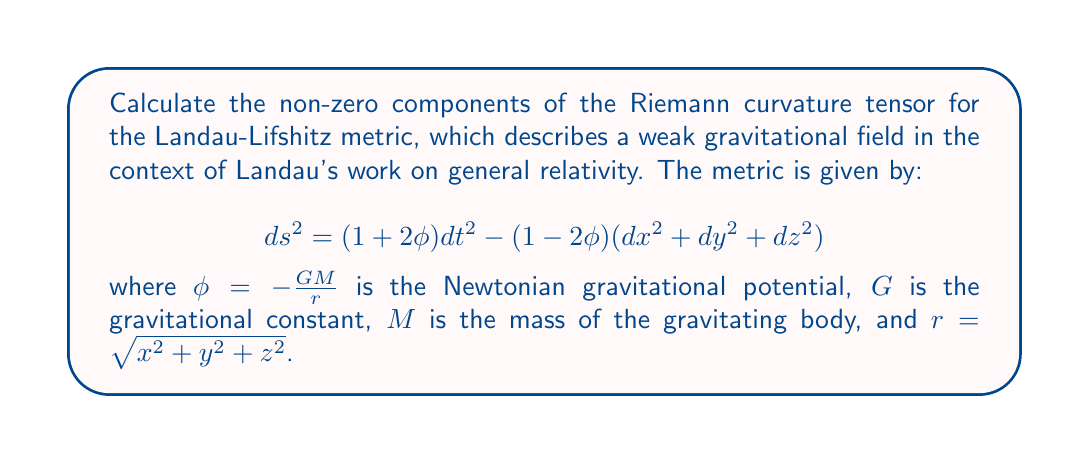Give your solution to this math problem. To calculate the Riemann curvature tensor, we'll follow these steps:

1) First, we need to calculate the Christoffel symbols. The non-zero Christoffel symbols for this metric are:

   $$\Gamma^0_{0i} = \Gamma^0_{i0} = \frac{\partial_i \phi}{1+2\phi}$$
   $$\Gamma^i_{00} = (1-2\phi)\partial_i \phi$$
   $$\Gamma^i_{jk} = -(\delta_{ij}\partial_k \phi + \delta_{ik}\partial_j \phi - \delta_{jk}\partial_i \phi)$$

   where $i,j,k = 1,2,3$ and $\partial_i = \frac{\partial}{\partial x^i}$.

2) The Riemann curvature tensor is given by:

   $$R^\rho_{\sigma\mu\nu} = \partial_\mu \Gamma^\rho_{\nu\sigma} - \partial_\nu \Gamma^\rho_{\mu\sigma} + \Gamma^\rho_{\mu\lambda}\Gamma^\lambda_{\nu\sigma} - \Gamma^\rho_{\nu\lambda}\Gamma^\lambda_{\mu\sigma}$$

3) Calculating the non-zero components:

   For $R^0_{i0j}$:
   $$R^0_{i0j} = \partial_i \Gamma^0_{0j} - \partial_0 \Gamma^0_{ij} + \Gamma^0_{i\lambda}\Gamma^\lambda_{0j} - \Gamma^0_{0\lambda}\Gamma^\lambda_{ij}$$
   $$= \partial_i (\frac{\partial_j \phi}{1+2\phi}) + \Gamma^0_{i0}\Gamma^0_{0j} - \Gamma^0_{00}\Gamma^j_{ij}$$
   $$\approx \partial_i \partial_j \phi - \partial_i \phi \partial_j \phi$$

   For $R^i_{j0k}$:
   $$R^i_{j0k} = \partial_0 \Gamma^i_{jk} - \partial_k \Gamma^i_{j0} + \Gamma^i_{0\lambda}\Gamma^\lambda_{jk} - \Gamma^i_{k\lambda}\Gamma^\lambda_{j0}$$
   $$= -\partial_k (\delta_{ij}\partial_0 \phi) + \Gamma^i_{00}\Gamma^0_{jk} - \Gamma^i_{k0}\Gamma^0_{j0}$$
   $$\approx \delta_{ij}\partial_k \partial_0 \phi$$

   For $R^i_{jkl}$:
   $$R^i_{jkl} = \partial_k \Gamma^i_{lj} - \partial_l \Gamma^i_{kj} + \Gamma^i_{k\lambda}\Gamma^\lambda_{lj} - \Gamma^i_{l\lambda}\Gamma^\lambda_{kj}$$
   $$\approx \delta_{il}\partial_k \partial_j \phi + \delta_{ij}\partial_l \partial_k \phi - \delta_{ik}\partial_l \partial_j \phi - \delta_{jl}\partial_i \partial_k \phi$$

4) In the weak field approximation, we can neglect terms of order $\phi^2$ and higher.

5) The potential $\phi = -\frac{GM}{r}$ satisfies the Poisson equation $\nabla^2 \phi = 4\pi G\rho$, where $\rho$ is the mass density.
Answer: $R^0_{i0j} \approx \partial_i \partial_j \phi$, $R^i_{j0k} \approx \delta_{ij}\partial_k \partial_0 \phi$, $R^i_{jkl} \approx \delta_{il}\partial_k \partial_j \phi + \delta_{ij}\partial_l \partial_k \phi - \delta_{ik}\partial_l \partial_j \phi - \delta_{jl}\partial_i \partial_k \phi$ 